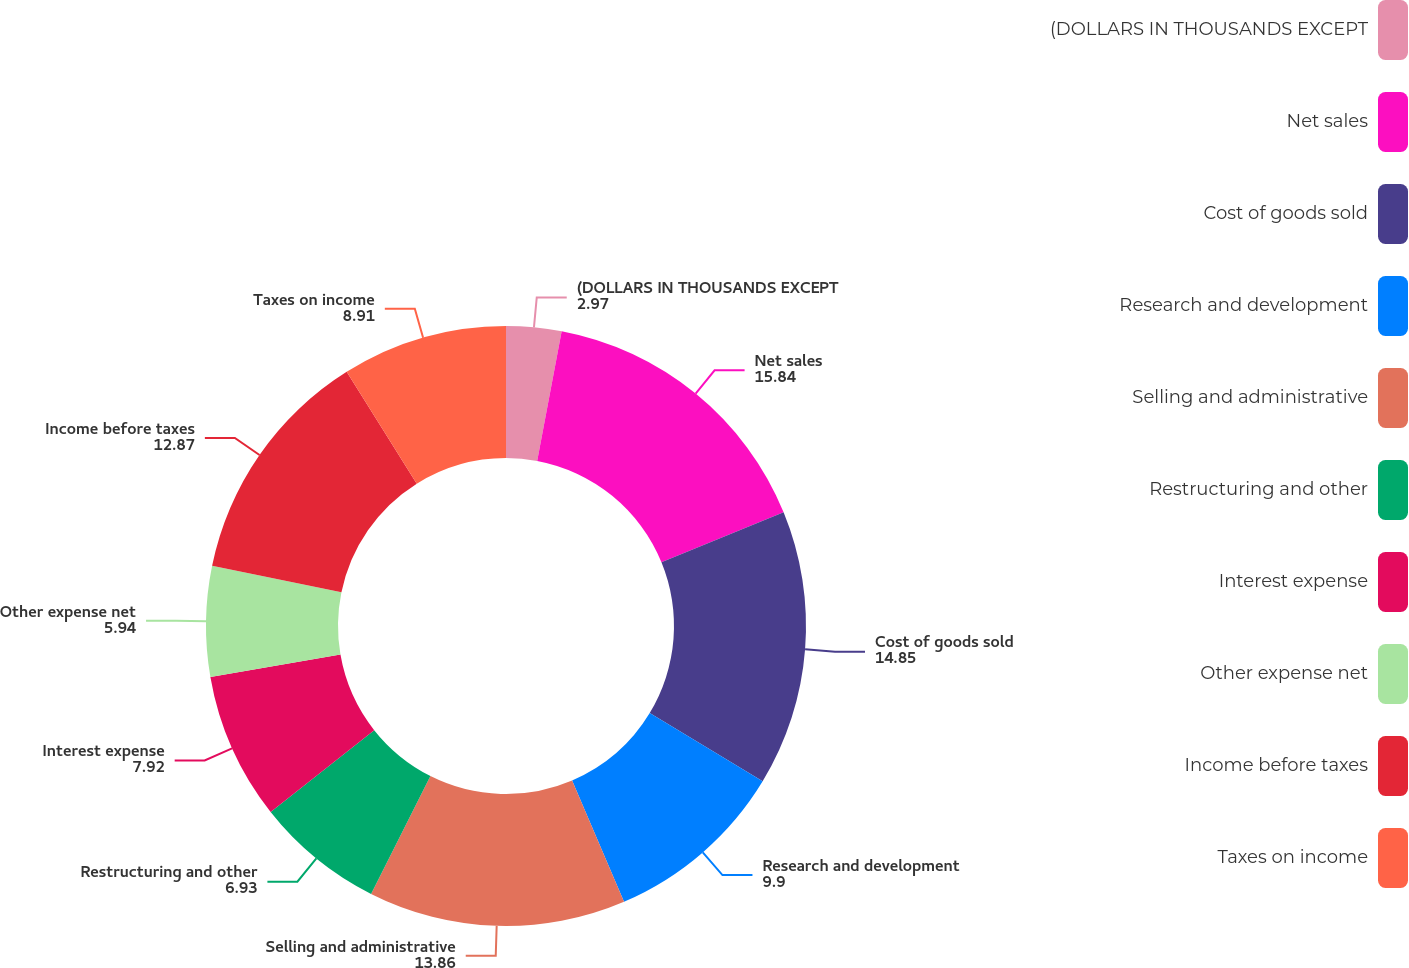Convert chart to OTSL. <chart><loc_0><loc_0><loc_500><loc_500><pie_chart><fcel>(DOLLARS IN THOUSANDS EXCEPT<fcel>Net sales<fcel>Cost of goods sold<fcel>Research and development<fcel>Selling and administrative<fcel>Restructuring and other<fcel>Interest expense<fcel>Other expense net<fcel>Income before taxes<fcel>Taxes on income<nl><fcel>2.97%<fcel>15.84%<fcel>14.85%<fcel>9.9%<fcel>13.86%<fcel>6.93%<fcel>7.92%<fcel>5.94%<fcel>12.87%<fcel>8.91%<nl></chart> 